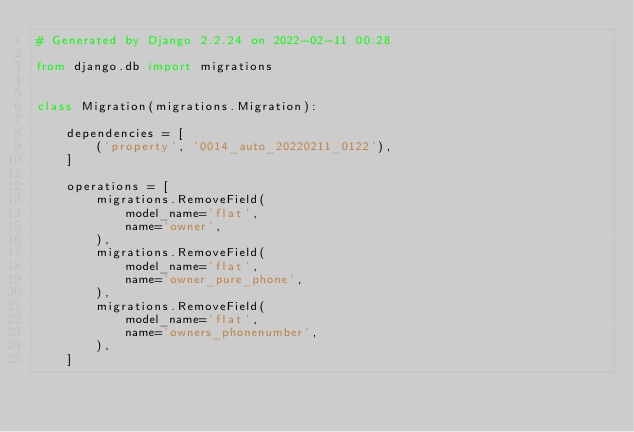Convert code to text. <code><loc_0><loc_0><loc_500><loc_500><_Python_># Generated by Django 2.2.24 on 2022-02-11 00:28

from django.db import migrations


class Migration(migrations.Migration):

    dependencies = [
        ('property', '0014_auto_20220211_0122'),
    ]

    operations = [
        migrations.RemoveField(
            model_name='flat',
            name='owner',
        ),
        migrations.RemoveField(
            model_name='flat',
            name='owner_pure_phone',
        ),
        migrations.RemoveField(
            model_name='flat',
            name='owners_phonenumber',
        ),
    ]
</code> 